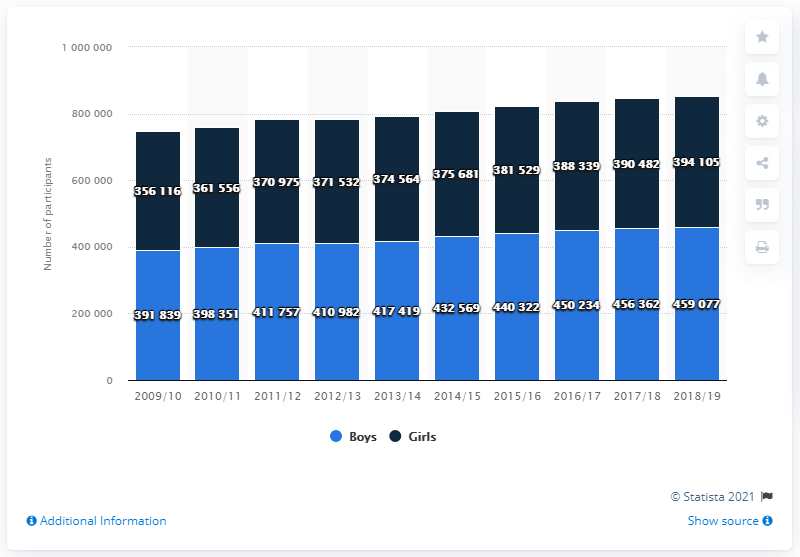Give some essential details in this illustration. In the 2018/19 high school soccer season, a total of 459,077 boys participated. 